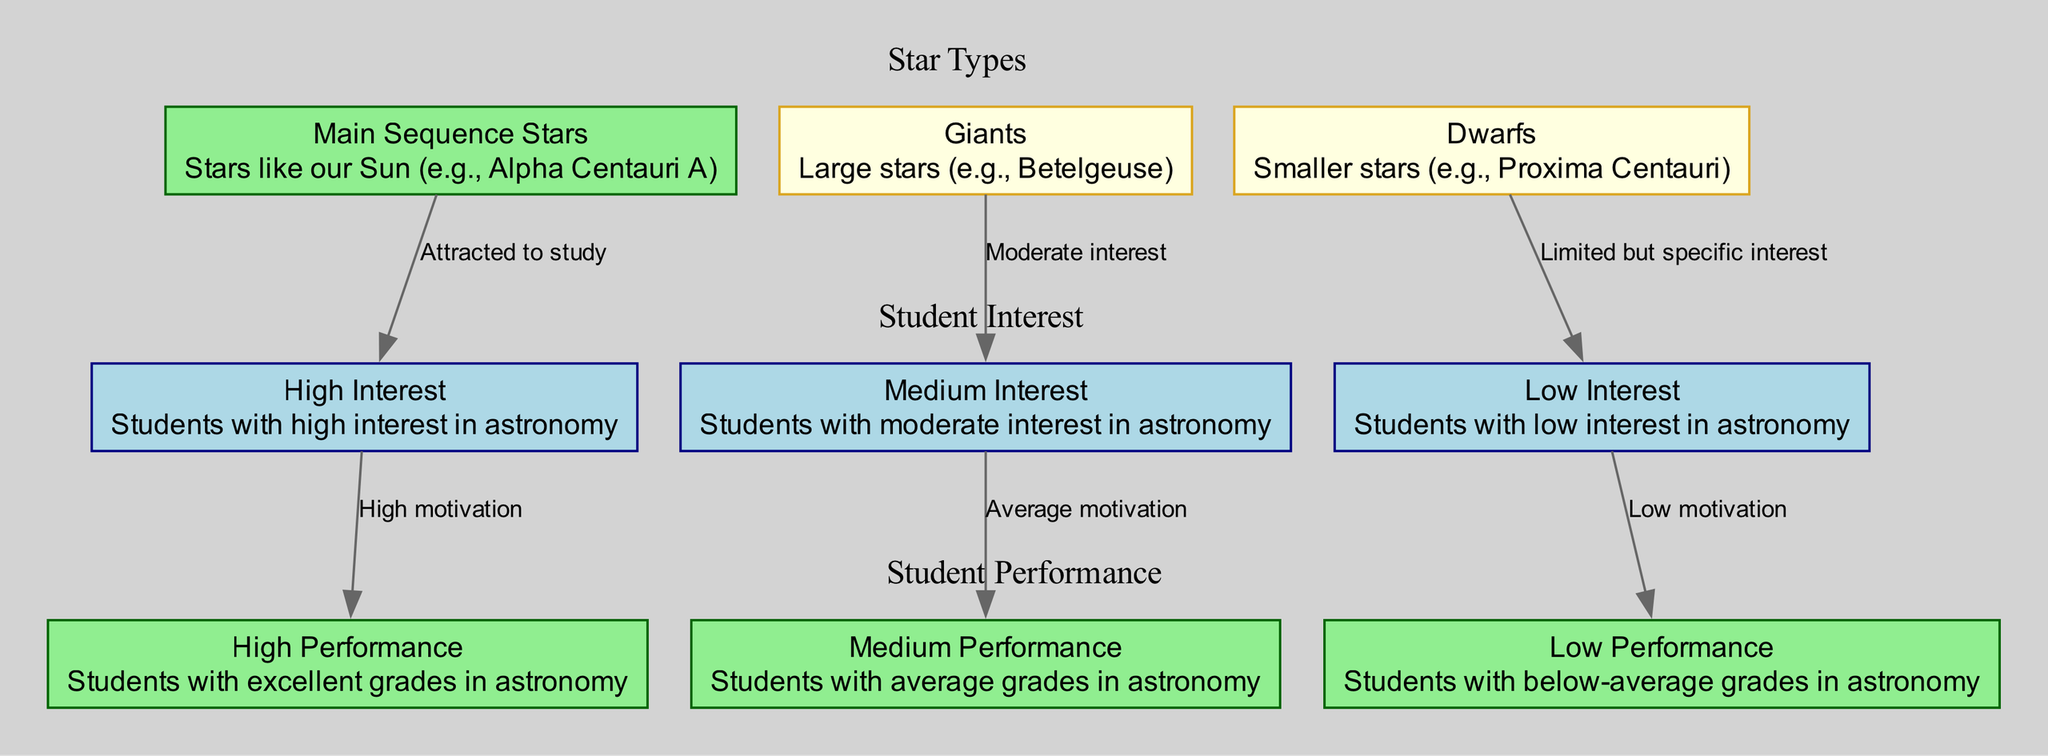What type of star is associated with high student interest? The diagram shows that Main Sequence Stars are linked to students with High Interest in astronomy through the edge labeled 'Attracted to study.' This indicates that students are particularly engaged with this type of star.
Answer: Main Sequence Stars How many types of student interest levels are represented? The diagram includes three distinct nodes for student interest levels: High Interest, Medium Interest, and Low Interest. Therefore, when counting these nodes, the total is three.
Answer: 3 Which star type corresponds to students with low performance? The Dwarf Stars are associated with students having Low Interest, which in turn correlates to Low Performance based on the edge labeled 'Low motivation.' Therefore, Dwarf Stars are linked to this performance level.
Answer: Dwarf Stars What is the relationship between Medium Interest students and their performance level? The diagram illustrates that Medium Interest students are connected to Medium Performance through the edge labeled 'Average motivation.' This indicates a moderate level of achievement per their interest level.
Answer: Medium Performance How many edges connect star types to student interest levels? By analyzing the diagram, we can count two edges originating from the star types to the student interest levels: one for Main Sequence Stars to High Interest, one for Giant Stars to Medium Interest, and one for Dwarf Stars to Low Interest. This results in a total of three connections (edges).
Answer: 3 What type of relationship exists between High Interest students and their performance? The edge labeled 'High motivation' explicitly indicates a positive relationship between High Interest students and High Performance. This suggests that students who are highly interested generally perform better in astronomy-related courses.
Answer: High motivation Which star type has students with specific but limited interest? The diagram clearly links Dwarf Stars to students with Low Interest through the edge labeled 'Limited but specific interest,' suggesting that while their interest is narrower, it is still present.
Answer: Dwarf Stars Which student performance level is associated with High Interest? The diagram indicates that High Interest students connect to High Performance through the edge 'High motivation.' This shows that high interest typically correlates with superior performance in astronomy courses.
Answer: High Performance What color represents the Dwarf Stars in the diagram? The node representing Dwarf Stars is shown with a fill color of 'lightyellow' and an outline of 'goldenrod,' making it visually distinct among the types of stars.
Answer: lightyellow 